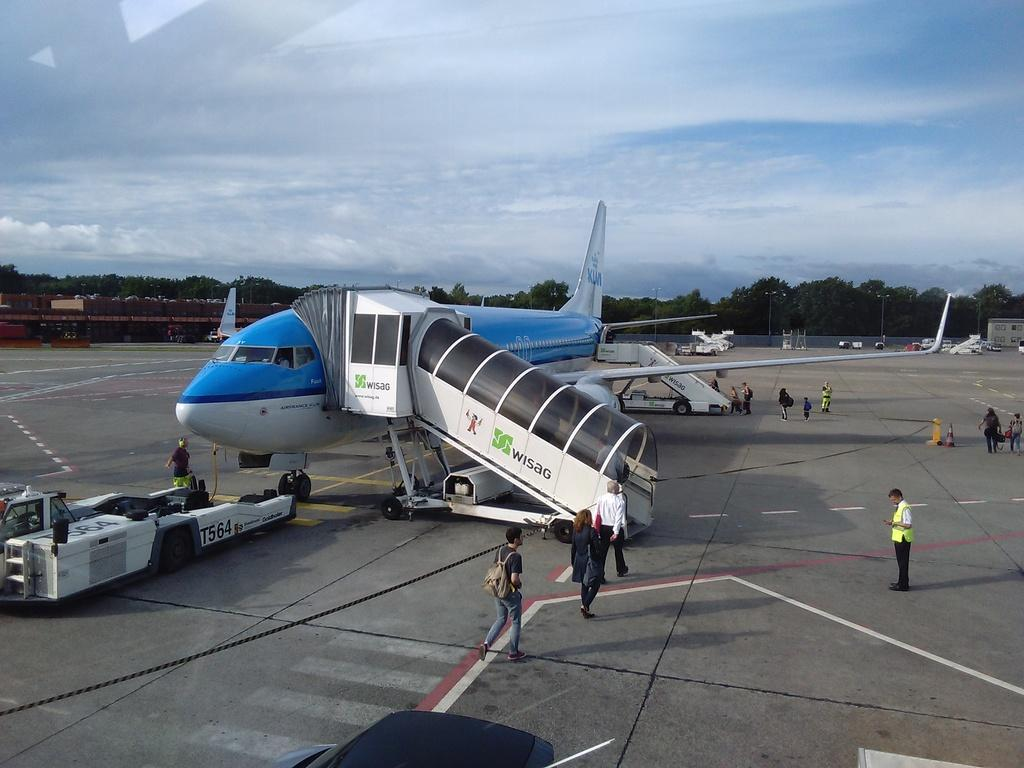<image>
Describe the image concisely. A small group of people are boarding a blue WISAG jet staircase. 